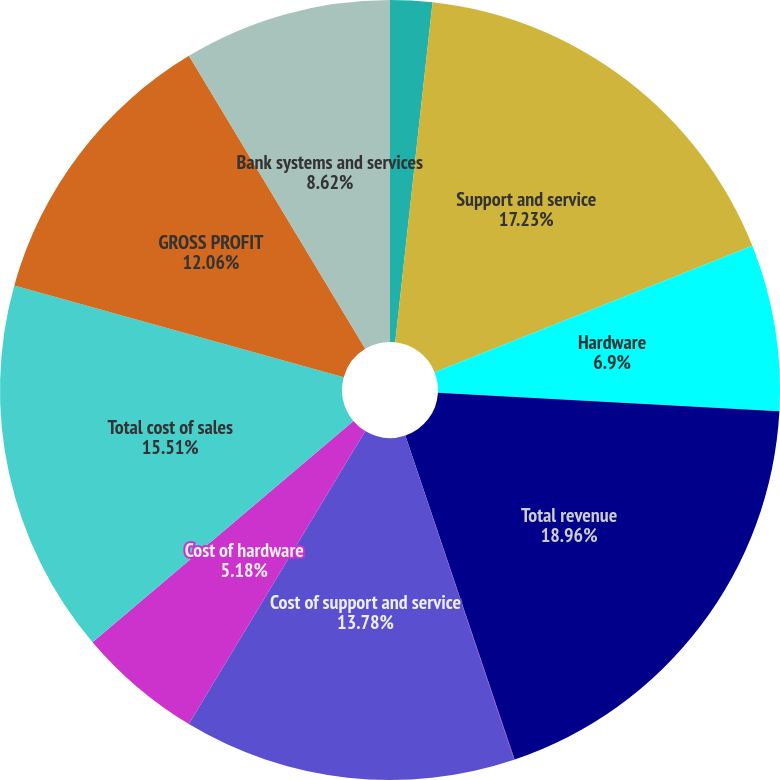Convert chart to OTSL. <chart><loc_0><loc_0><loc_500><loc_500><pie_chart><fcel>License<fcel>Support and service<fcel>Hardware<fcel>Total revenue<fcel>Cost of license<fcel>Cost of support and service<fcel>Cost of hardware<fcel>Total cost of sales<fcel>GROSS PROFIT<fcel>Bank systems and services<nl><fcel>1.74%<fcel>17.23%<fcel>6.9%<fcel>18.95%<fcel>0.02%<fcel>13.78%<fcel>5.18%<fcel>15.51%<fcel>12.06%<fcel>8.62%<nl></chart> 